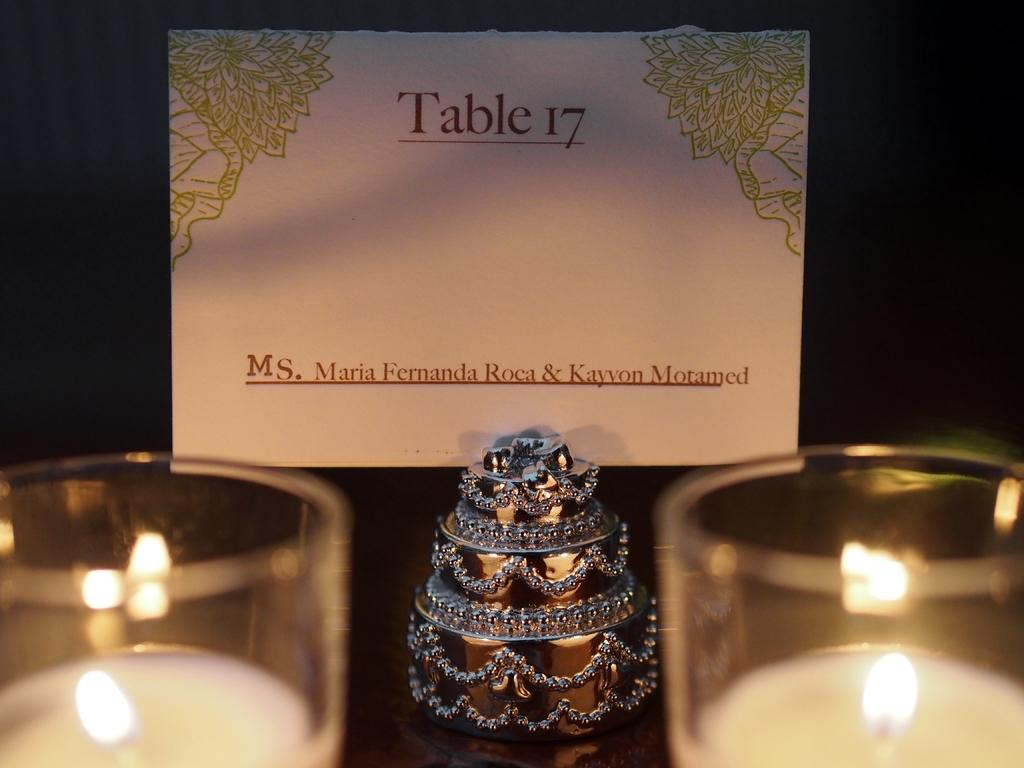How many candles are present in the image? There are two candles in the image. What is located in front of the candles? There is an object in front of the candles. Is there any text visible in the image? Yes, there is a note with text behind the object. How many babies are visible in the image? There are no babies present in the image. What is the income of the person who wrote the note in the image? There is no information about the income of the person who wrote the note in the image. 